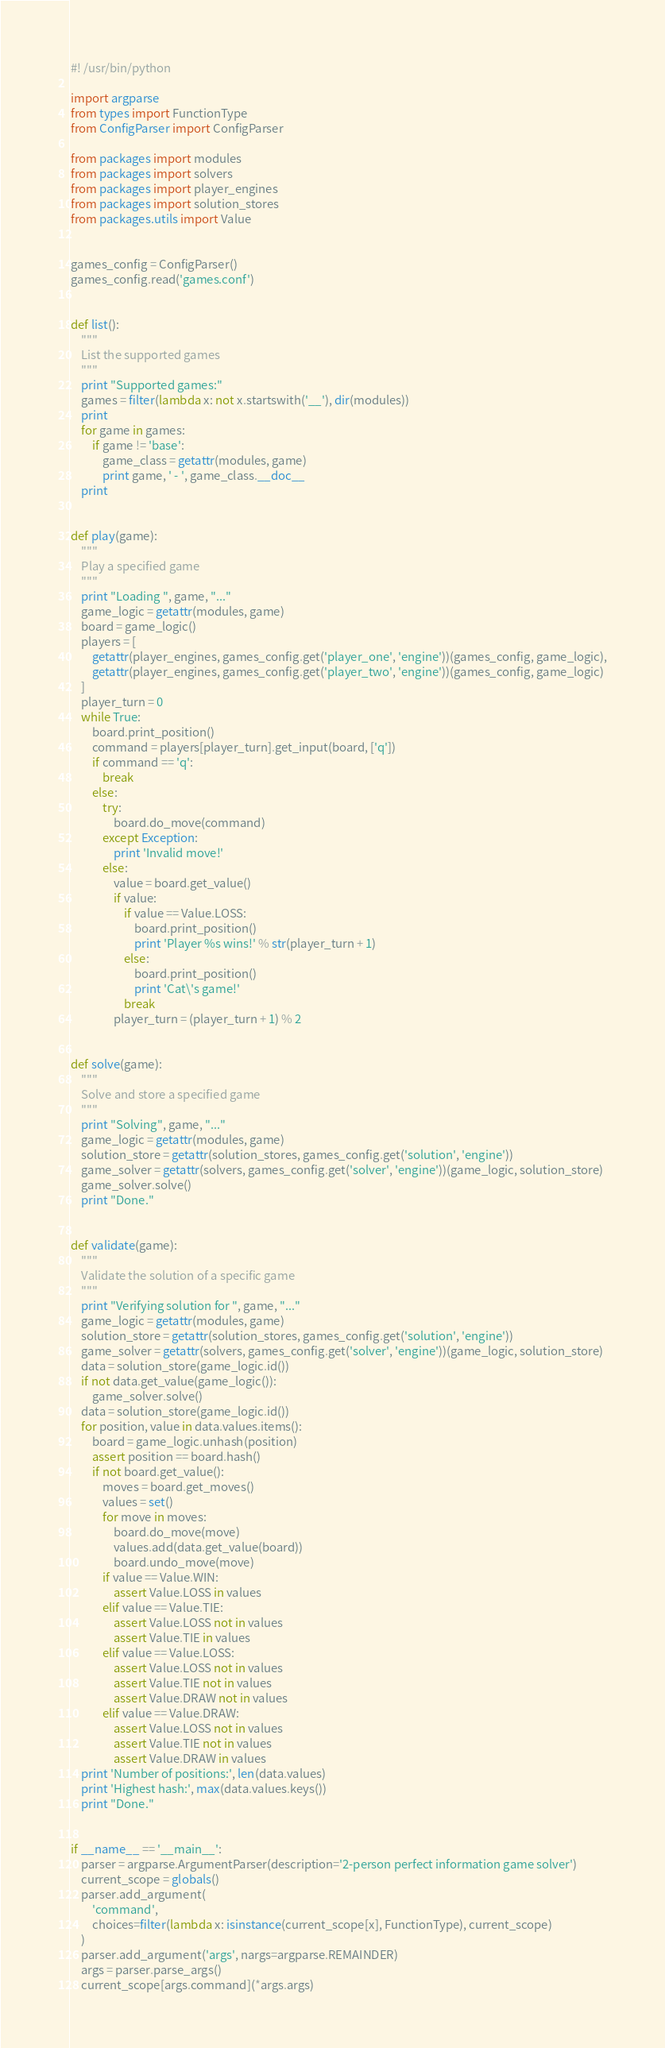<code> <loc_0><loc_0><loc_500><loc_500><_Python_>#! /usr/bin/python

import argparse
from types import FunctionType
from ConfigParser import ConfigParser

from packages import modules
from packages import solvers
from packages import player_engines
from packages import solution_stores
from packages.utils import Value


games_config = ConfigParser()
games_config.read('games.conf')


def list():
    """
    List the supported games
    """
    print "Supported games:"
    games = filter(lambda x: not x.startswith('__'), dir(modules))
    print
    for game in games:
        if game != 'base':
            game_class = getattr(modules, game)
            print game, ' - ', game_class.__doc__
    print


def play(game):
    """
    Play a specified game
    """
    print "Loading ", game, "..."
    game_logic = getattr(modules, game)
    board = game_logic()
    players = [
        getattr(player_engines, games_config.get('player_one', 'engine'))(games_config, game_logic),
        getattr(player_engines, games_config.get('player_two', 'engine'))(games_config, game_logic)
    ]
    player_turn = 0
    while True:
        board.print_position()
        command = players[player_turn].get_input(board, ['q'])
        if command == 'q':
            break
        else:
            try:
                board.do_move(command)
            except Exception:
                print 'Invalid move!'
            else:
                value = board.get_value()
                if value:
                    if value == Value.LOSS:
                        board.print_position()
                        print 'Player %s wins!' % str(player_turn + 1)
                    else:
                        board.print_position()
                        print 'Cat\'s game!'
                    break
                player_turn = (player_turn + 1) % 2


def solve(game):
    """
    Solve and store a specified game
    """
    print "Solving", game, "..."
    game_logic = getattr(modules, game)
    solution_store = getattr(solution_stores, games_config.get('solution', 'engine'))
    game_solver = getattr(solvers, games_config.get('solver', 'engine'))(game_logic, solution_store)
    game_solver.solve()
    print "Done."


def validate(game):
    """
    Validate the solution of a specific game
    """
    print "Verifying solution for ", game, "..."
    game_logic = getattr(modules, game)
    solution_store = getattr(solution_stores, games_config.get('solution', 'engine'))
    game_solver = getattr(solvers, games_config.get('solver', 'engine'))(game_logic, solution_store)
    data = solution_store(game_logic.id())
    if not data.get_value(game_logic()):
        game_solver.solve()
    data = solution_store(game_logic.id())
    for position, value in data.values.items():
        board = game_logic.unhash(position)
        assert position == board.hash()
        if not board.get_value():
            moves = board.get_moves()
            values = set()
            for move in moves:
                board.do_move(move)
                values.add(data.get_value(board))
                board.undo_move(move)
            if value == Value.WIN:
                assert Value.LOSS in values
            elif value == Value.TIE:
                assert Value.LOSS not in values
                assert Value.TIE in values
            elif value == Value.LOSS:
                assert Value.LOSS not in values
                assert Value.TIE not in values
                assert Value.DRAW not in values
            elif value == Value.DRAW:
                assert Value.LOSS not in values
                assert Value.TIE not in values
                assert Value.DRAW in values
    print 'Number of positions:', len(data.values)
    print 'Highest hash:', max(data.values.keys())
    print "Done."


if __name__ == '__main__':
    parser = argparse.ArgumentParser(description='2-person perfect information game solver')
    current_scope = globals()
    parser.add_argument(
        'command',
        choices=filter(lambda x: isinstance(current_scope[x], FunctionType), current_scope)
    )
    parser.add_argument('args', nargs=argparse.REMAINDER)
    args = parser.parse_args()
    current_scope[args.command](*args.args)
</code> 